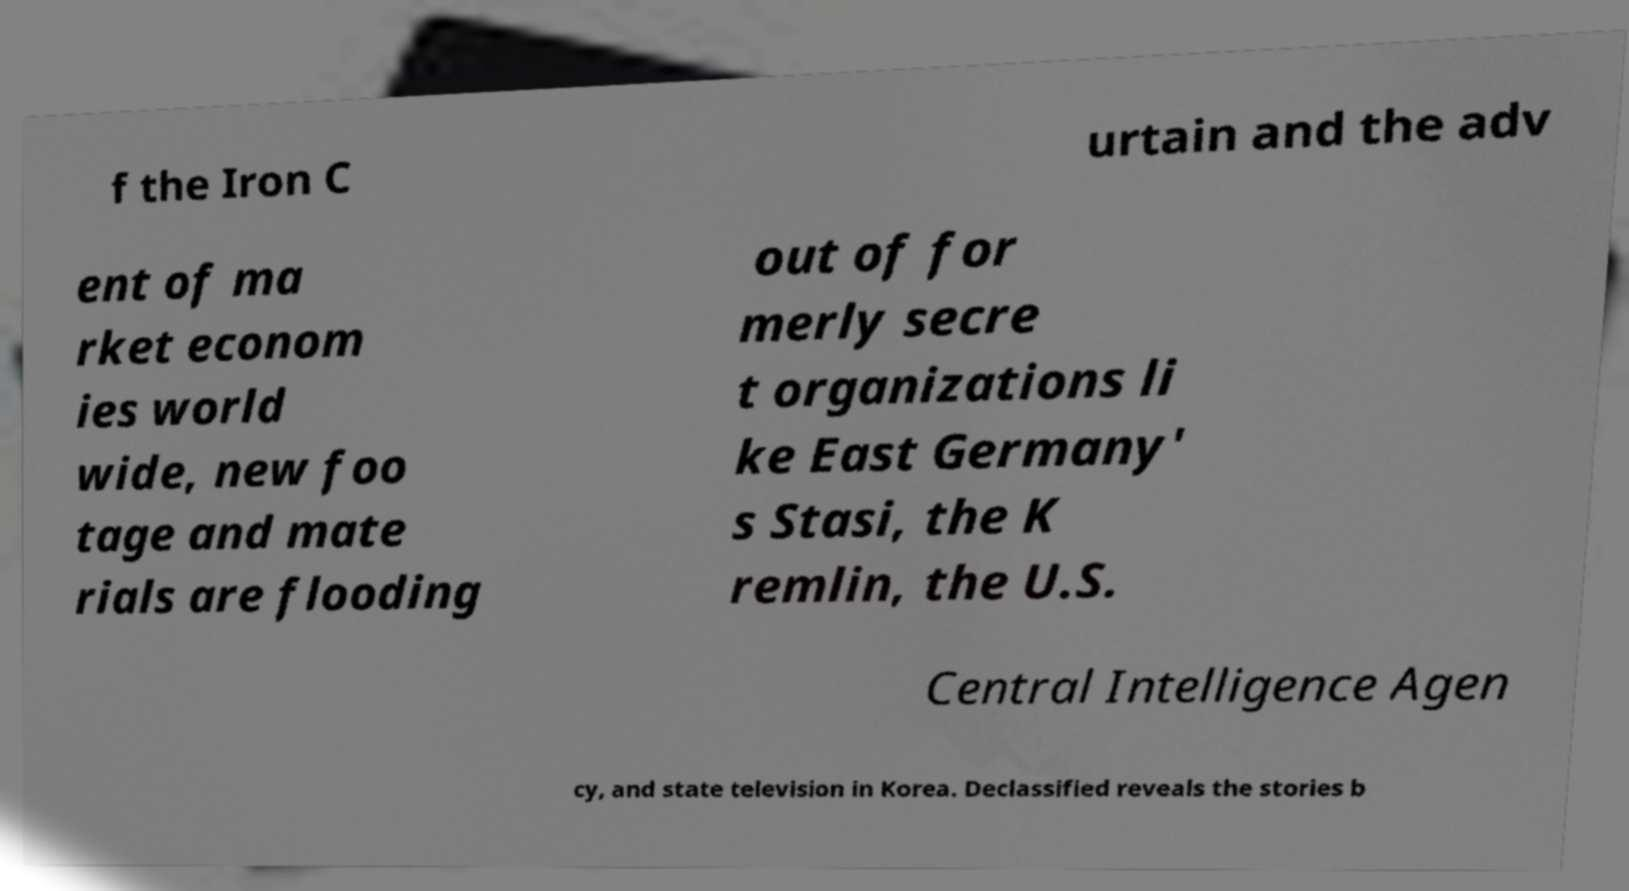Can you accurately transcribe the text from the provided image for me? f the Iron C urtain and the adv ent of ma rket econom ies world wide, new foo tage and mate rials are flooding out of for merly secre t organizations li ke East Germany' s Stasi, the K remlin, the U.S. Central Intelligence Agen cy, and state television in Korea. Declassified reveals the stories b 